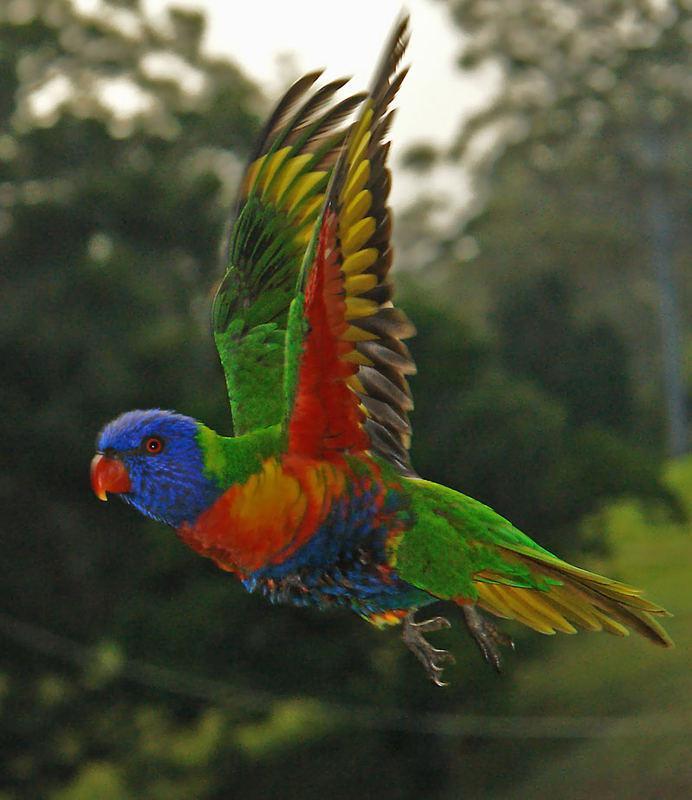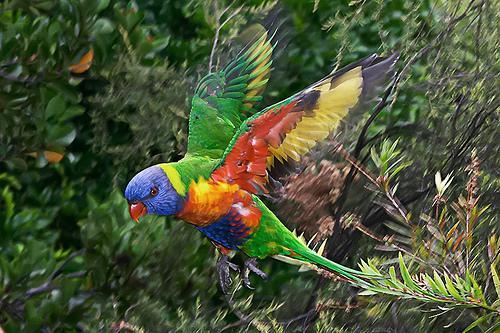The first image is the image on the left, the second image is the image on the right. For the images displayed, is the sentence "Both images show a parrot that is flying" factually correct? Answer yes or no. Yes. The first image is the image on the left, the second image is the image on the right. Given the left and right images, does the statement "Only parrots in flight are shown in the images." hold true? Answer yes or no. Yes. 